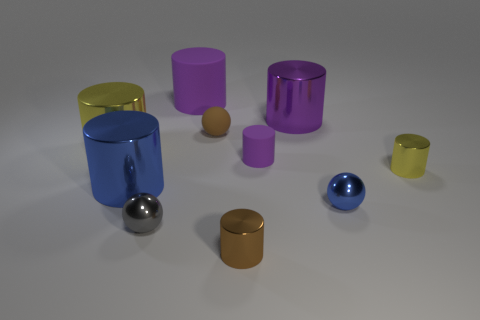How many yellow cylinders must be subtracted to get 1 yellow cylinders? 1 Subtract all purple blocks. How many purple cylinders are left? 3 Subtract all tiny brown cylinders. How many cylinders are left? 6 Subtract all yellow cylinders. How many cylinders are left? 5 Subtract 1 cylinders. How many cylinders are left? 6 Subtract all blue cylinders. Subtract all blue spheres. How many cylinders are left? 6 Subtract all spheres. How many objects are left? 7 Subtract 1 gray balls. How many objects are left? 9 Subtract all small purple objects. Subtract all small purple things. How many objects are left? 8 Add 7 purple metal cylinders. How many purple metal cylinders are left? 8 